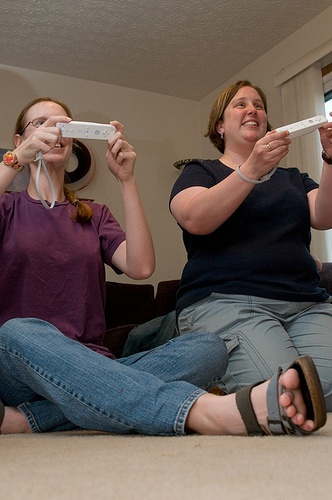Describe the objects in this image and their specific colors. I can see people in gray, black, and blue tones, people in gray, black, and brown tones, couch in gray, black, and maroon tones, remote in gray, darkgray, and lightgray tones, and remote in gray, lightgray, and darkgray tones in this image. 